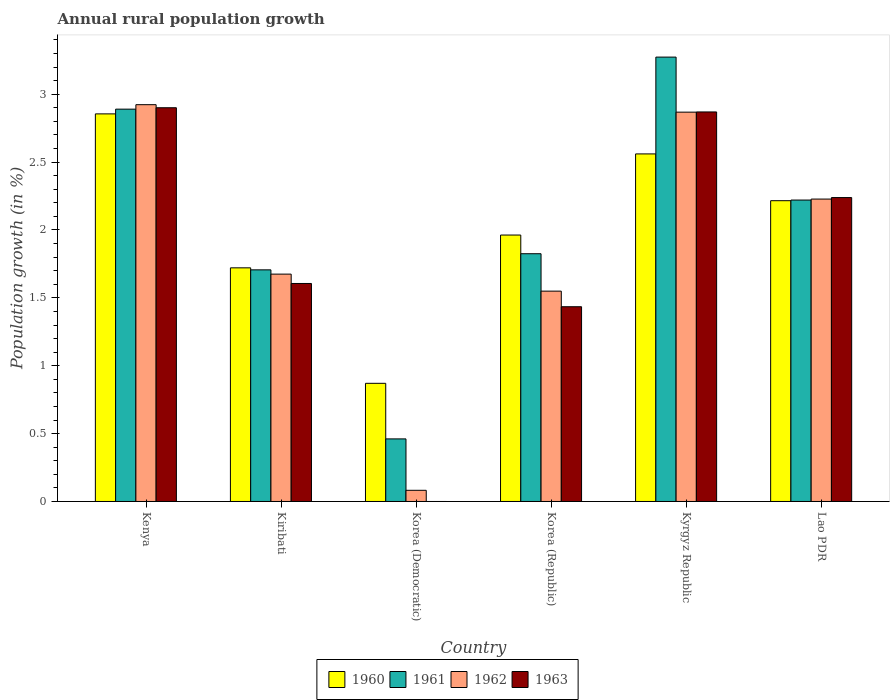Are the number of bars per tick equal to the number of legend labels?
Offer a very short reply. No. Are the number of bars on each tick of the X-axis equal?
Your answer should be very brief. No. How many bars are there on the 2nd tick from the left?
Your answer should be compact. 4. How many bars are there on the 5th tick from the right?
Provide a short and direct response. 4. What is the label of the 3rd group of bars from the left?
Offer a terse response. Korea (Democratic). Across all countries, what is the maximum percentage of rural population growth in 1960?
Give a very brief answer. 2.86. Across all countries, what is the minimum percentage of rural population growth in 1960?
Provide a succinct answer. 0.87. In which country was the percentage of rural population growth in 1962 maximum?
Your answer should be very brief. Kenya. What is the total percentage of rural population growth in 1961 in the graph?
Ensure brevity in your answer.  12.38. What is the difference between the percentage of rural population growth in 1961 in Kyrgyz Republic and that in Lao PDR?
Provide a succinct answer. 1.05. What is the difference between the percentage of rural population growth in 1960 in Kyrgyz Republic and the percentage of rural population growth in 1962 in Lao PDR?
Provide a short and direct response. 0.33. What is the average percentage of rural population growth in 1960 per country?
Provide a short and direct response. 2.03. What is the difference between the percentage of rural population growth of/in 1961 and percentage of rural population growth of/in 1963 in Korea (Republic)?
Give a very brief answer. 0.39. In how many countries, is the percentage of rural population growth in 1960 greater than 3.3 %?
Your response must be concise. 0. What is the ratio of the percentage of rural population growth in 1961 in Kenya to that in Korea (Democratic)?
Provide a succinct answer. 6.27. Is the percentage of rural population growth in 1961 in Korea (Democratic) less than that in Lao PDR?
Make the answer very short. Yes. Is the difference between the percentage of rural population growth in 1961 in Kiribati and Korea (Republic) greater than the difference between the percentage of rural population growth in 1963 in Kiribati and Korea (Republic)?
Your response must be concise. No. What is the difference between the highest and the second highest percentage of rural population growth in 1961?
Make the answer very short. -0.38. What is the difference between the highest and the lowest percentage of rural population growth in 1963?
Offer a very short reply. 2.9. In how many countries, is the percentage of rural population growth in 1963 greater than the average percentage of rural population growth in 1963 taken over all countries?
Give a very brief answer. 3. Is it the case that in every country, the sum of the percentage of rural population growth in 1960 and percentage of rural population growth in 1963 is greater than the percentage of rural population growth in 1962?
Provide a short and direct response. Yes. What is the difference between two consecutive major ticks on the Y-axis?
Provide a succinct answer. 0.5. Are the values on the major ticks of Y-axis written in scientific E-notation?
Give a very brief answer. No. Does the graph contain any zero values?
Your answer should be compact. Yes. Does the graph contain grids?
Make the answer very short. No. How are the legend labels stacked?
Provide a short and direct response. Horizontal. What is the title of the graph?
Your answer should be very brief. Annual rural population growth. Does "1989" appear as one of the legend labels in the graph?
Give a very brief answer. No. What is the label or title of the X-axis?
Make the answer very short. Country. What is the label or title of the Y-axis?
Keep it short and to the point. Population growth (in %). What is the Population growth (in %) of 1960 in Kenya?
Offer a very short reply. 2.86. What is the Population growth (in %) in 1961 in Kenya?
Offer a very short reply. 2.89. What is the Population growth (in %) of 1962 in Kenya?
Provide a short and direct response. 2.92. What is the Population growth (in %) of 1963 in Kenya?
Your response must be concise. 2.9. What is the Population growth (in %) of 1960 in Kiribati?
Ensure brevity in your answer.  1.72. What is the Population growth (in %) of 1961 in Kiribati?
Make the answer very short. 1.71. What is the Population growth (in %) of 1962 in Kiribati?
Ensure brevity in your answer.  1.67. What is the Population growth (in %) of 1963 in Kiribati?
Your answer should be compact. 1.61. What is the Population growth (in %) in 1960 in Korea (Democratic)?
Keep it short and to the point. 0.87. What is the Population growth (in %) in 1961 in Korea (Democratic)?
Provide a succinct answer. 0.46. What is the Population growth (in %) in 1962 in Korea (Democratic)?
Provide a succinct answer. 0.08. What is the Population growth (in %) in 1960 in Korea (Republic)?
Give a very brief answer. 1.96. What is the Population growth (in %) in 1961 in Korea (Republic)?
Your answer should be compact. 1.83. What is the Population growth (in %) in 1962 in Korea (Republic)?
Offer a terse response. 1.55. What is the Population growth (in %) of 1963 in Korea (Republic)?
Ensure brevity in your answer.  1.43. What is the Population growth (in %) of 1960 in Kyrgyz Republic?
Give a very brief answer. 2.56. What is the Population growth (in %) of 1961 in Kyrgyz Republic?
Offer a very short reply. 3.27. What is the Population growth (in %) of 1962 in Kyrgyz Republic?
Give a very brief answer. 2.87. What is the Population growth (in %) of 1963 in Kyrgyz Republic?
Your answer should be very brief. 2.87. What is the Population growth (in %) of 1960 in Lao PDR?
Provide a short and direct response. 2.22. What is the Population growth (in %) in 1961 in Lao PDR?
Ensure brevity in your answer.  2.22. What is the Population growth (in %) of 1962 in Lao PDR?
Keep it short and to the point. 2.23. What is the Population growth (in %) in 1963 in Lao PDR?
Ensure brevity in your answer.  2.24. Across all countries, what is the maximum Population growth (in %) in 1960?
Offer a terse response. 2.86. Across all countries, what is the maximum Population growth (in %) of 1961?
Keep it short and to the point. 3.27. Across all countries, what is the maximum Population growth (in %) in 1962?
Provide a short and direct response. 2.92. Across all countries, what is the maximum Population growth (in %) in 1963?
Ensure brevity in your answer.  2.9. Across all countries, what is the minimum Population growth (in %) of 1960?
Offer a terse response. 0.87. Across all countries, what is the minimum Population growth (in %) in 1961?
Your answer should be very brief. 0.46. Across all countries, what is the minimum Population growth (in %) of 1962?
Make the answer very short. 0.08. What is the total Population growth (in %) in 1960 in the graph?
Your answer should be compact. 12.19. What is the total Population growth (in %) in 1961 in the graph?
Make the answer very short. 12.38. What is the total Population growth (in %) of 1962 in the graph?
Ensure brevity in your answer.  11.33. What is the total Population growth (in %) in 1963 in the graph?
Your response must be concise. 11.05. What is the difference between the Population growth (in %) in 1960 in Kenya and that in Kiribati?
Your response must be concise. 1.13. What is the difference between the Population growth (in %) of 1961 in Kenya and that in Kiribati?
Provide a succinct answer. 1.18. What is the difference between the Population growth (in %) in 1962 in Kenya and that in Kiribati?
Keep it short and to the point. 1.25. What is the difference between the Population growth (in %) of 1963 in Kenya and that in Kiribati?
Give a very brief answer. 1.29. What is the difference between the Population growth (in %) of 1960 in Kenya and that in Korea (Democratic)?
Provide a short and direct response. 1.98. What is the difference between the Population growth (in %) in 1961 in Kenya and that in Korea (Democratic)?
Your response must be concise. 2.43. What is the difference between the Population growth (in %) of 1962 in Kenya and that in Korea (Democratic)?
Provide a succinct answer. 2.84. What is the difference between the Population growth (in %) of 1960 in Kenya and that in Korea (Republic)?
Your answer should be very brief. 0.89. What is the difference between the Population growth (in %) in 1961 in Kenya and that in Korea (Republic)?
Make the answer very short. 1.07. What is the difference between the Population growth (in %) in 1962 in Kenya and that in Korea (Republic)?
Your answer should be very brief. 1.37. What is the difference between the Population growth (in %) of 1963 in Kenya and that in Korea (Republic)?
Your response must be concise. 1.47. What is the difference between the Population growth (in %) of 1960 in Kenya and that in Kyrgyz Republic?
Keep it short and to the point. 0.29. What is the difference between the Population growth (in %) of 1961 in Kenya and that in Kyrgyz Republic?
Make the answer very short. -0.38. What is the difference between the Population growth (in %) of 1962 in Kenya and that in Kyrgyz Republic?
Ensure brevity in your answer.  0.06. What is the difference between the Population growth (in %) in 1963 in Kenya and that in Kyrgyz Republic?
Your answer should be very brief. 0.03. What is the difference between the Population growth (in %) of 1960 in Kenya and that in Lao PDR?
Your answer should be very brief. 0.64. What is the difference between the Population growth (in %) in 1961 in Kenya and that in Lao PDR?
Provide a succinct answer. 0.67. What is the difference between the Population growth (in %) in 1962 in Kenya and that in Lao PDR?
Make the answer very short. 0.7. What is the difference between the Population growth (in %) of 1963 in Kenya and that in Lao PDR?
Your answer should be very brief. 0.66. What is the difference between the Population growth (in %) of 1960 in Kiribati and that in Korea (Democratic)?
Offer a terse response. 0.85. What is the difference between the Population growth (in %) in 1961 in Kiribati and that in Korea (Democratic)?
Keep it short and to the point. 1.25. What is the difference between the Population growth (in %) of 1962 in Kiribati and that in Korea (Democratic)?
Your answer should be compact. 1.59. What is the difference between the Population growth (in %) in 1960 in Kiribati and that in Korea (Republic)?
Give a very brief answer. -0.24. What is the difference between the Population growth (in %) of 1961 in Kiribati and that in Korea (Republic)?
Your response must be concise. -0.12. What is the difference between the Population growth (in %) of 1962 in Kiribati and that in Korea (Republic)?
Ensure brevity in your answer.  0.13. What is the difference between the Population growth (in %) of 1963 in Kiribati and that in Korea (Republic)?
Offer a very short reply. 0.17. What is the difference between the Population growth (in %) of 1960 in Kiribati and that in Kyrgyz Republic?
Your answer should be very brief. -0.84. What is the difference between the Population growth (in %) in 1961 in Kiribati and that in Kyrgyz Republic?
Offer a very short reply. -1.57. What is the difference between the Population growth (in %) of 1962 in Kiribati and that in Kyrgyz Republic?
Offer a very short reply. -1.19. What is the difference between the Population growth (in %) of 1963 in Kiribati and that in Kyrgyz Republic?
Make the answer very short. -1.26. What is the difference between the Population growth (in %) in 1960 in Kiribati and that in Lao PDR?
Give a very brief answer. -0.49. What is the difference between the Population growth (in %) of 1961 in Kiribati and that in Lao PDR?
Give a very brief answer. -0.51. What is the difference between the Population growth (in %) in 1962 in Kiribati and that in Lao PDR?
Offer a terse response. -0.55. What is the difference between the Population growth (in %) in 1963 in Kiribati and that in Lao PDR?
Offer a very short reply. -0.63. What is the difference between the Population growth (in %) of 1960 in Korea (Democratic) and that in Korea (Republic)?
Keep it short and to the point. -1.09. What is the difference between the Population growth (in %) in 1961 in Korea (Democratic) and that in Korea (Republic)?
Provide a succinct answer. -1.36. What is the difference between the Population growth (in %) of 1962 in Korea (Democratic) and that in Korea (Republic)?
Your response must be concise. -1.47. What is the difference between the Population growth (in %) of 1960 in Korea (Democratic) and that in Kyrgyz Republic?
Make the answer very short. -1.69. What is the difference between the Population growth (in %) of 1961 in Korea (Democratic) and that in Kyrgyz Republic?
Keep it short and to the point. -2.81. What is the difference between the Population growth (in %) in 1962 in Korea (Democratic) and that in Kyrgyz Republic?
Offer a terse response. -2.79. What is the difference between the Population growth (in %) of 1960 in Korea (Democratic) and that in Lao PDR?
Keep it short and to the point. -1.35. What is the difference between the Population growth (in %) of 1961 in Korea (Democratic) and that in Lao PDR?
Your response must be concise. -1.76. What is the difference between the Population growth (in %) in 1962 in Korea (Democratic) and that in Lao PDR?
Keep it short and to the point. -2.15. What is the difference between the Population growth (in %) in 1960 in Korea (Republic) and that in Kyrgyz Republic?
Provide a succinct answer. -0.6. What is the difference between the Population growth (in %) of 1961 in Korea (Republic) and that in Kyrgyz Republic?
Provide a succinct answer. -1.45. What is the difference between the Population growth (in %) of 1962 in Korea (Republic) and that in Kyrgyz Republic?
Offer a very short reply. -1.32. What is the difference between the Population growth (in %) in 1963 in Korea (Republic) and that in Kyrgyz Republic?
Ensure brevity in your answer.  -1.43. What is the difference between the Population growth (in %) in 1960 in Korea (Republic) and that in Lao PDR?
Give a very brief answer. -0.25. What is the difference between the Population growth (in %) in 1961 in Korea (Republic) and that in Lao PDR?
Your response must be concise. -0.4. What is the difference between the Population growth (in %) in 1962 in Korea (Republic) and that in Lao PDR?
Your answer should be very brief. -0.68. What is the difference between the Population growth (in %) in 1963 in Korea (Republic) and that in Lao PDR?
Offer a terse response. -0.8. What is the difference between the Population growth (in %) in 1960 in Kyrgyz Republic and that in Lao PDR?
Provide a succinct answer. 0.34. What is the difference between the Population growth (in %) in 1961 in Kyrgyz Republic and that in Lao PDR?
Offer a very short reply. 1.05. What is the difference between the Population growth (in %) of 1962 in Kyrgyz Republic and that in Lao PDR?
Provide a succinct answer. 0.64. What is the difference between the Population growth (in %) of 1963 in Kyrgyz Republic and that in Lao PDR?
Ensure brevity in your answer.  0.63. What is the difference between the Population growth (in %) of 1960 in Kenya and the Population growth (in %) of 1961 in Kiribati?
Your response must be concise. 1.15. What is the difference between the Population growth (in %) of 1960 in Kenya and the Population growth (in %) of 1962 in Kiribati?
Offer a terse response. 1.18. What is the difference between the Population growth (in %) in 1960 in Kenya and the Population growth (in %) in 1963 in Kiribati?
Your response must be concise. 1.25. What is the difference between the Population growth (in %) in 1961 in Kenya and the Population growth (in %) in 1962 in Kiribati?
Keep it short and to the point. 1.22. What is the difference between the Population growth (in %) in 1961 in Kenya and the Population growth (in %) in 1963 in Kiribati?
Offer a very short reply. 1.28. What is the difference between the Population growth (in %) of 1962 in Kenya and the Population growth (in %) of 1963 in Kiribati?
Provide a succinct answer. 1.32. What is the difference between the Population growth (in %) of 1960 in Kenya and the Population growth (in %) of 1961 in Korea (Democratic)?
Offer a terse response. 2.39. What is the difference between the Population growth (in %) of 1960 in Kenya and the Population growth (in %) of 1962 in Korea (Democratic)?
Offer a very short reply. 2.77. What is the difference between the Population growth (in %) of 1961 in Kenya and the Population growth (in %) of 1962 in Korea (Democratic)?
Offer a very short reply. 2.81. What is the difference between the Population growth (in %) of 1960 in Kenya and the Population growth (in %) of 1961 in Korea (Republic)?
Your answer should be compact. 1.03. What is the difference between the Population growth (in %) in 1960 in Kenya and the Population growth (in %) in 1962 in Korea (Republic)?
Your answer should be compact. 1.31. What is the difference between the Population growth (in %) of 1960 in Kenya and the Population growth (in %) of 1963 in Korea (Republic)?
Provide a succinct answer. 1.42. What is the difference between the Population growth (in %) of 1961 in Kenya and the Population growth (in %) of 1962 in Korea (Republic)?
Your answer should be very brief. 1.34. What is the difference between the Population growth (in %) in 1961 in Kenya and the Population growth (in %) in 1963 in Korea (Republic)?
Ensure brevity in your answer.  1.46. What is the difference between the Population growth (in %) of 1962 in Kenya and the Population growth (in %) of 1963 in Korea (Republic)?
Offer a terse response. 1.49. What is the difference between the Population growth (in %) of 1960 in Kenya and the Population growth (in %) of 1961 in Kyrgyz Republic?
Provide a short and direct response. -0.42. What is the difference between the Population growth (in %) of 1960 in Kenya and the Population growth (in %) of 1962 in Kyrgyz Republic?
Give a very brief answer. -0.01. What is the difference between the Population growth (in %) of 1960 in Kenya and the Population growth (in %) of 1963 in Kyrgyz Republic?
Keep it short and to the point. -0.01. What is the difference between the Population growth (in %) of 1961 in Kenya and the Population growth (in %) of 1962 in Kyrgyz Republic?
Offer a very short reply. 0.02. What is the difference between the Population growth (in %) of 1961 in Kenya and the Population growth (in %) of 1963 in Kyrgyz Republic?
Your answer should be compact. 0.02. What is the difference between the Population growth (in %) of 1962 in Kenya and the Population growth (in %) of 1963 in Kyrgyz Republic?
Provide a succinct answer. 0.05. What is the difference between the Population growth (in %) in 1960 in Kenya and the Population growth (in %) in 1961 in Lao PDR?
Give a very brief answer. 0.63. What is the difference between the Population growth (in %) of 1960 in Kenya and the Population growth (in %) of 1962 in Lao PDR?
Offer a terse response. 0.63. What is the difference between the Population growth (in %) in 1960 in Kenya and the Population growth (in %) in 1963 in Lao PDR?
Offer a terse response. 0.62. What is the difference between the Population growth (in %) in 1961 in Kenya and the Population growth (in %) in 1962 in Lao PDR?
Offer a very short reply. 0.66. What is the difference between the Population growth (in %) of 1961 in Kenya and the Population growth (in %) of 1963 in Lao PDR?
Make the answer very short. 0.65. What is the difference between the Population growth (in %) in 1962 in Kenya and the Population growth (in %) in 1963 in Lao PDR?
Make the answer very short. 0.68. What is the difference between the Population growth (in %) of 1960 in Kiribati and the Population growth (in %) of 1961 in Korea (Democratic)?
Offer a very short reply. 1.26. What is the difference between the Population growth (in %) of 1960 in Kiribati and the Population growth (in %) of 1962 in Korea (Democratic)?
Your answer should be very brief. 1.64. What is the difference between the Population growth (in %) in 1961 in Kiribati and the Population growth (in %) in 1962 in Korea (Democratic)?
Provide a succinct answer. 1.62. What is the difference between the Population growth (in %) in 1960 in Kiribati and the Population growth (in %) in 1961 in Korea (Republic)?
Your answer should be very brief. -0.1. What is the difference between the Population growth (in %) of 1960 in Kiribati and the Population growth (in %) of 1962 in Korea (Republic)?
Offer a terse response. 0.17. What is the difference between the Population growth (in %) of 1960 in Kiribati and the Population growth (in %) of 1963 in Korea (Republic)?
Give a very brief answer. 0.29. What is the difference between the Population growth (in %) in 1961 in Kiribati and the Population growth (in %) in 1962 in Korea (Republic)?
Provide a succinct answer. 0.16. What is the difference between the Population growth (in %) in 1961 in Kiribati and the Population growth (in %) in 1963 in Korea (Republic)?
Offer a terse response. 0.27. What is the difference between the Population growth (in %) of 1962 in Kiribati and the Population growth (in %) of 1963 in Korea (Republic)?
Ensure brevity in your answer.  0.24. What is the difference between the Population growth (in %) in 1960 in Kiribati and the Population growth (in %) in 1961 in Kyrgyz Republic?
Your response must be concise. -1.55. What is the difference between the Population growth (in %) in 1960 in Kiribati and the Population growth (in %) in 1962 in Kyrgyz Republic?
Provide a succinct answer. -1.15. What is the difference between the Population growth (in %) in 1960 in Kiribati and the Population growth (in %) in 1963 in Kyrgyz Republic?
Give a very brief answer. -1.15. What is the difference between the Population growth (in %) of 1961 in Kiribati and the Population growth (in %) of 1962 in Kyrgyz Republic?
Your answer should be compact. -1.16. What is the difference between the Population growth (in %) of 1961 in Kiribati and the Population growth (in %) of 1963 in Kyrgyz Republic?
Offer a very short reply. -1.16. What is the difference between the Population growth (in %) in 1962 in Kiribati and the Population growth (in %) in 1963 in Kyrgyz Republic?
Keep it short and to the point. -1.19. What is the difference between the Population growth (in %) of 1960 in Kiribati and the Population growth (in %) of 1961 in Lao PDR?
Provide a succinct answer. -0.5. What is the difference between the Population growth (in %) in 1960 in Kiribati and the Population growth (in %) in 1962 in Lao PDR?
Keep it short and to the point. -0.51. What is the difference between the Population growth (in %) in 1960 in Kiribati and the Population growth (in %) in 1963 in Lao PDR?
Offer a very short reply. -0.52. What is the difference between the Population growth (in %) of 1961 in Kiribati and the Population growth (in %) of 1962 in Lao PDR?
Ensure brevity in your answer.  -0.52. What is the difference between the Population growth (in %) in 1961 in Kiribati and the Population growth (in %) in 1963 in Lao PDR?
Make the answer very short. -0.53. What is the difference between the Population growth (in %) of 1962 in Kiribati and the Population growth (in %) of 1963 in Lao PDR?
Offer a terse response. -0.56. What is the difference between the Population growth (in %) in 1960 in Korea (Democratic) and the Population growth (in %) in 1961 in Korea (Republic)?
Make the answer very short. -0.95. What is the difference between the Population growth (in %) in 1960 in Korea (Democratic) and the Population growth (in %) in 1962 in Korea (Republic)?
Make the answer very short. -0.68. What is the difference between the Population growth (in %) of 1960 in Korea (Democratic) and the Population growth (in %) of 1963 in Korea (Republic)?
Make the answer very short. -0.56. What is the difference between the Population growth (in %) in 1961 in Korea (Democratic) and the Population growth (in %) in 1962 in Korea (Republic)?
Your answer should be compact. -1.09. What is the difference between the Population growth (in %) of 1961 in Korea (Democratic) and the Population growth (in %) of 1963 in Korea (Republic)?
Offer a very short reply. -0.97. What is the difference between the Population growth (in %) of 1962 in Korea (Democratic) and the Population growth (in %) of 1963 in Korea (Republic)?
Give a very brief answer. -1.35. What is the difference between the Population growth (in %) in 1960 in Korea (Democratic) and the Population growth (in %) in 1961 in Kyrgyz Republic?
Make the answer very short. -2.4. What is the difference between the Population growth (in %) of 1960 in Korea (Democratic) and the Population growth (in %) of 1962 in Kyrgyz Republic?
Provide a succinct answer. -2. What is the difference between the Population growth (in %) of 1960 in Korea (Democratic) and the Population growth (in %) of 1963 in Kyrgyz Republic?
Ensure brevity in your answer.  -2. What is the difference between the Population growth (in %) of 1961 in Korea (Democratic) and the Population growth (in %) of 1962 in Kyrgyz Republic?
Your answer should be very brief. -2.41. What is the difference between the Population growth (in %) of 1961 in Korea (Democratic) and the Population growth (in %) of 1963 in Kyrgyz Republic?
Keep it short and to the point. -2.41. What is the difference between the Population growth (in %) in 1962 in Korea (Democratic) and the Population growth (in %) in 1963 in Kyrgyz Republic?
Your answer should be compact. -2.79. What is the difference between the Population growth (in %) in 1960 in Korea (Democratic) and the Population growth (in %) in 1961 in Lao PDR?
Provide a short and direct response. -1.35. What is the difference between the Population growth (in %) in 1960 in Korea (Democratic) and the Population growth (in %) in 1962 in Lao PDR?
Your response must be concise. -1.36. What is the difference between the Population growth (in %) of 1960 in Korea (Democratic) and the Population growth (in %) of 1963 in Lao PDR?
Your answer should be very brief. -1.37. What is the difference between the Population growth (in %) of 1961 in Korea (Democratic) and the Population growth (in %) of 1962 in Lao PDR?
Offer a very short reply. -1.77. What is the difference between the Population growth (in %) of 1961 in Korea (Democratic) and the Population growth (in %) of 1963 in Lao PDR?
Your response must be concise. -1.78. What is the difference between the Population growth (in %) of 1962 in Korea (Democratic) and the Population growth (in %) of 1963 in Lao PDR?
Keep it short and to the point. -2.16. What is the difference between the Population growth (in %) of 1960 in Korea (Republic) and the Population growth (in %) of 1961 in Kyrgyz Republic?
Provide a short and direct response. -1.31. What is the difference between the Population growth (in %) of 1960 in Korea (Republic) and the Population growth (in %) of 1962 in Kyrgyz Republic?
Your answer should be compact. -0.91. What is the difference between the Population growth (in %) of 1960 in Korea (Republic) and the Population growth (in %) of 1963 in Kyrgyz Republic?
Keep it short and to the point. -0.91. What is the difference between the Population growth (in %) in 1961 in Korea (Republic) and the Population growth (in %) in 1962 in Kyrgyz Republic?
Your answer should be compact. -1.04. What is the difference between the Population growth (in %) of 1961 in Korea (Republic) and the Population growth (in %) of 1963 in Kyrgyz Republic?
Offer a terse response. -1.04. What is the difference between the Population growth (in %) of 1962 in Korea (Republic) and the Population growth (in %) of 1963 in Kyrgyz Republic?
Provide a succinct answer. -1.32. What is the difference between the Population growth (in %) in 1960 in Korea (Republic) and the Population growth (in %) in 1961 in Lao PDR?
Your answer should be very brief. -0.26. What is the difference between the Population growth (in %) in 1960 in Korea (Republic) and the Population growth (in %) in 1962 in Lao PDR?
Offer a very short reply. -0.26. What is the difference between the Population growth (in %) of 1960 in Korea (Republic) and the Population growth (in %) of 1963 in Lao PDR?
Offer a very short reply. -0.28. What is the difference between the Population growth (in %) in 1961 in Korea (Republic) and the Population growth (in %) in 1962 in Lao PDR?
Ensure brevity in your answer.  -0.4. What is the difference between the Population growth (in %) of 1961 in Korea (Republic) and the Population growth (in %) of 1963 in Lao PDR?
Keep it short and to the point. -0.41. What is the difference between the Population growth (in %) of 1962 in Korea (Republic) and the Population growth (in %) of 1963 in Lao PDR?
Provide a succinct answer. -0.69. What is the difference between the Population growth (in %) in 1960 in Kyrgyz Republic and the Population growth (in %) in 1961 in Lao PDR?
Your answer should be compact. 0.34. What is the difference between the Population growth (in %) in 1960 in Kyrgyz Republic and the Population growth (in %) in 1962 in Lao PDR?
Your answer should be compact. 0.33. What is the difference between the Population growth (in %) in 1960 in Kyrgyz Republic and the Population growth (in %) in 1963 in Lao PDR?
Keep it short and to the point. 0.32. What is the difference between the Population growth (in %) of 1961 in Kyrgyz Republic and the Population growth (in %) of 1962 in Lao PDR?
Make the answer very short. 1.05. What is the difference between the Population growth (in %) in 1961 in Kyrgyz Republic and the Population growth (in %) in 1963 in Lao PDR?
Provide a short and direct response. 1.03. What is the difference between the Population growth (in %) in 1962 in Kyrgyz Republic and the Population growth (in %) in 1963 in Lao PDR?
Give a very brief answer. 0.63. What is the average Population growth (in %) of 1960 per country?
Ensure brevity in your answer.  2.03. What is the average Population growth (in %) in 1961 per country?
Your response must be concise. 2.06. What is the average Population growth (in %) of 1962 per country?
Provide a succinct answer. 1.89. What is the average Population growth (in %) in 1963 per country?
Offer a terse response. 1.84. What is the difference between the Population growth (in %) of 1960 and Population growth (in %) of 1961 in Kenya?
Provide a short and direct response. -0.03. What is the difference between the Population growth (in %) of 1960 and Population growth (in %) of 1962 in Kenya?
Provide a short and direct response. -0.07. What is the difference between the Population growth (in %) in 1960 and Population growth (in %) in 1963 in Kenya?
Provide a succinct answer. -0.05. What is the difference between the Population growth (in %) in 1961 and Population growth (in %) in 1962 in Kenya?
Offer a very short reply. -0.03. What is the difference between the Population growth (in %) of 1961 and Population growth (in %) of 1963 in Kenya?
Provide a succinct answer. -0.01. What is the difference between the Population growth (in %) in 1962 and Population growth (in %) in 1963 in Kenya?
Provide a short and direct response. 0.02. What is the difference between the Population growth (in %) of 1960 and Population growth (in %) of 1961 in Kiribati?
Keep it short and to the point. 0.01. What is the difference between the Population growth (in %) in 1960 and Population growth (in %) in 1962 in Kiribati?
Your answer should be very brief. 0.05. What is the difference between the Population growth (in %) of 1960 and Population growth (in %) of 1963 in Kiribati?
Provide a short and direct response. 0.12. What is the difference between the Population growth (in %) of 1961 and Population growth (in %) of 1962 in Kiribati?
Give a very brief answer. 0.03. What is the difference between the Population growth (in %) in 1961 and Population growth (in %) in 1963 in Kiribati?
Your response must be concise. 0.1. What is the difference between the Population growth (in %) of 1962 and Population growth (in %) of 1963 in Kiribati?
Ensure brevity in your answer.  0.07. What is the difference between the Population growth (in %) in 1960 and Population growth (in %) in 1961 in Korea (Democratic)?
Provide a short and direct response. 0.41. What is the difference between the Population growth (in %) of 1960 and Population growth (in %) of 1962 in Korea (Democratic)?
Offer a very short reply. 0.79. What is the difference between the Population growth (in %) in 1961 and Population growth (in %) in 1962 in Korea (Democratic)?
Your answer should be very brief. 0.38. What is the difference between the Population growth (in %) in 1960 and Population growth (in %) in 1961 in Korea (Republic)?
Make the answer very short. 0.14. What is the difference between the Population growth (in %) in 1960 and Population growth (in %) in 1962 in Korea (Republic)?
Your answer should be very brief. 0.41. What is the difference between the Population growth (in %) in 1960 and Population growth (in %) in 1963 in Korea (Republic)?
Provide a succinct answer. 0.53. What is the difference between the Population growth (in %) in 1961 and Population growth (in %) in 1962 in Korea (Republic)?
Your answer should be very brief. 0.28. What is the difference between the Population growth (in %) in 1961 and Population growth (in %) in 1963 in Korea (Republic)?
Your response must be concise. 0.39. What is the difference between the Population growth (in %) in 1962 and Population growth (in %) in 1963 in Korea (Republic)?
Give a very brief answer. 0.11. What is the difference between the Population growth (in %) of 1960 and Population growth (in %) of 1961 in Kyrgyz Republic?
Your answer should be very brief. -0.71. What is the difference between the Population growth (in %) of 1960 and Population growth (in %) of 1962 in Kyrgyz Republic?
Your response must be concise. -0.31. What is the difference between the Population growth (in %) of 1960 and Population growth (in %) of 1963 in Kyrgyz Republic?
Your response must be concise. -0.31. What is the difference between the Population growth (in %) in 1961 and Population growth (in %) in 1962 in Kyrgyz Republic?
Make the answer very short. 0.41. What is the difference between the Population growth (in %) of 1961 and Population growth (in %) of 1963 in Kyrgyz Republic?
Make the answer very short. 0.4. What is the difference between the Population growth (in %) of 1962 and Population growth (in %) of 1963 in Kyrgyz Republic?
Give a very brief answer. -0. What is the difference between the Population growth (in %) in 1960 and Population growth (in %) in 1961 in Lao PDR?
Your answer should be compact. -0. What is the difference between the Population growth (in %) of 1960 and Population growth (in %) of 1962 in Lao PDR?
Keep it short and to the point. -0.01. What is the difference between the Population growth (in %) of 1960 and Population growth (in %) of 1963 in Lao PDR?
Give a very brief answer. -0.02. What is the difference between the Population growth (in %) in 1961 and Population growth (in %) in 1962 in Lao PDR?
Your answer should be very brief. -0.01. What is the difference between the Population growth (in %) of 1961 and Population growth (in %) of 1963 in Lao PDR?
Provide a succinct answer. -0.02. What is the difference between the Population growth (in %) in 1962 and Population growth (in %) in 1963 in Lao PDR?
Keep it short and to the point. -0.01. What is the ratio of the Population growth (in %) of 1960 in Kenya to that in Kiribati?
Your answer should be very brief. 1.66. What is the ratio of the Population growth (in %) in 1961 in Kenya to that in Kiribati?
Ensure brevity in your answer.  1.69. What is the ratio of the Population growth (in %) in 1962 in Kenya to that in Kiribati?
Your answer should be compact. 1.75. What is the ratio of the Population growth (in %) of 1963 in Kenya to that in Kiribati?
Your answer should be very brief. 1.81. What is the ratio of the Population growth (in %) of 1960 in Kenya to that in Korea (Democratic)?
Your response must be concise. 3.28. What is the ratio of the Population growth (in %) of 1961 in Kenya to that in Korea (Democratic)?
Your response must be concise. 6.27. What is the ratio of the Population growth (in %) of 1962 in Kenya to that in Korea (Democratic)?
Give a very brief answer. 35.53. What is the ratio of the Population growth (in %) in 1960 in Kenya to that in Korea (Republic)?
Provide a short and direct response. 1.45. What is the ratio of the Population growth (in %) of 1961 in Kenya to that in Korea (Republic)?
Provide a succinct answer. 1.58. What is the ratio of the Population growth (in %) of 1962 in Kenya to that in Korea (Republic)?
Offer a very short reply. 1.89. What is the ratio of the Population growth (in %) in 1963 in Kenya to that in Korea (Republic)?
Your answer should be compact. 2.02. What is the ratio of the Population growth (in %) of 1960 in Kenya to that in Kyrgyz Republic?
Your answer should be compact. 1.12. What is the ratio of the Population growth (in %) of 1961 in Kenya to that in Kyrgyz Republic?
Offer a terse response. 0.88. What is the ratio of the Population growth (in %) of 1962 in Kenya to that in Kyrgyz Republic?
Your response must be concise. 1.02. What is the ratio of the Population growth (in %) in 1963 in Kenya to that in Kyrgyz Republic?
Make the answer very short. 1.01. What is the ratio of the Population growth (in %) of 1960 in Kenya to that in Lao PDR?
Make the answer very short. 1.29. What is the ratio of the Population growth (in %) in 1961 in Kenya to that in Lao PDR?
Your response must be concise. 1.3. What is the ratio of the Population growth (in %) in 1962 in Kenya to that in Lao PDR?
Give a very brief answer. 1.31. What is the ratio of the Population growth (in %) of 1963 in Kenya to that in Lao PDR?
Give a very brief answer. 1.3. What is the ratio of the Population growth (in %) in 1960 in Kiribati to that in Korea (Democratic)?
Your answer should be very brief. 1.98. What is the ratio of the Population growth (in %) of 1961 in Kiribati to that in Korea (Democratic)?
Make the answer very short. 3.7. What is the ratio of the Population growth (in %) of 1962 in Kiribati to that in Korea (Democratic)?
Provide a succinct answer. 20.35. What is the ratio of the Population growth (in %) in 1960 in Kiribati to that in Korea (Republic)?
Provide a succinct answer. 0.88. What is the ratio of the Population growth (in %) in 1961 in Kiribati to that in Korea (Republic)?
Your answer should be very brief. 0.93. What is the ratio of the Population growth (in %) in 1962 in Kiribati to that in Korea (Republic)?
Your answer should be very brief. 1.08. What is the ratio of the Population growth (in %) in 1963 in Kiribati to that in Korea (Republic)?
Provide a succinct answer. 1.12. What is the ratio of the Population growth (in %) in 1960 in Kiribati to that in Kyrgyz Republic?
Keep it short and to the point. 0.67. What is the ratio of the Population growth (in %) of 1961 in Kiribati to that in Kyrgyz Republic?
Provide a succinct answer. 0.52. What is the ratio of the Population growth (in %) in 1962 in Kiribati to that in Kyrgyz Republic?
Your response must be concise. 0.58. What is the ratio of the Population growth (in %) of 1963 in Kiribati to that in Kyrgyz Republic?
Your response must be concise. 0.56. What is the ratio of the Population growth (in %) in 1960 in Kiribati to that in Lao PDR?
Your response must be concise. 0.78. What is the ratio of the Population growth (in %) in 1961 in Kiribati to that in Lao PDR?
Make the answer very short. 0.77. What is the ratio of the Population growth (in %) of 1962 in Kiribati to that in Lao PDR?
Your response must be concise. 0.75. What is the ratio of the Population growth (in %) of 1963 in Kiribati to that in Lao PDR?
Provide a succinct answer. 0.72. What is the ratio of the Population growth (in %) in 1960 in Korea (Democratic) to that in Korea (Republic)?
Give a very brief answer. 0.44. What is the ratio of the Population growth (in %) of 1961 in Korea (Democratic) to that in Korea (Republic)?
Keep it short and to the point. 0.25. What is the ratio of the Population growth (in %) of 1962 in Korea (Democratic) to that in Korea (Republic)?
Your response must be concise. 0.05. What is the ratio of the Population growth (in %) of 1960 in Korea (Democratic) to that in Kyrgyz Republic?
Your answer should be very brief. 0.34. What is the ratio of the Population growth (in %) of 1961 in Korea (Democratic) to that in Kyrgyz Republic?
Make the answer very short. 0.14. What is the ratio of the Population growth (in %) in 1962 in Korea (Democratic) to that in Kyrgyz Republic?
Your response must be concise. 0.03. What is the ratio of the Population growth (in %) in 1960 in Korea (Democratic) to that in Lao PDR?
Ensure brevity in your answer.  0.39. What is the ratio of the Population growth (in %) in 1961 in Korea (Democratic) to that in Lao PDR?
Give a very brief answer. 0.21. What is the ratio of the Population growth (in %) in 1962 in Korea (Democratic) to that in Lao PDR?
Make the answer very short. 0.04. What is the ratio of the Population growth (in %) in 1960 in Korea (Republic) to that in Kyrgyz Republic?
Your answer should be very brief. 0.77. What is the ratio of the Population growth (in %) of 1961 in Korea (Republic) to that in Kyrgyz Republic?
Your answer should be very brief. 0.56. What is the ratio of the Population growth (in %) in 1962 in Korea (Republic) to that in Kyrgyz Republic?
Keep it short and to the point. 0.54. What is the ratio of the Population growth (in %) of 1963 in Korea (Republic) to that in Kyrgyz Republic?
Keep it short and to the point. 0.5. What is the ratio of the Population growth (in %) in 1960 in Korea (Republic) to that in Lao PDR?
Offer a very short reply. 0.89. What is the ratio of the Population growth (in %) of 1961 in Korea (Republic) to that in Lao PDR?
Provide a succinct answer. 0.82. What is the ratio of the Population growth (in %) of 1962 in Korea (Republic) to that in Lao PDR?
Ensure brevity in your answer.  0.7. What is the ratio of the Population growth (in %) of 1963 in Korea (Republic) to that in Lao PDR?
Provide a succinct answer. 0.64. What is the ratio of the Population growth (in %) of 1960 in Kyrgyz Republic to that in Lao PDR?
Your answer should be very brief. 1.16. What is the ratio of the Population growth (in %) of 1961 in Kyrgyz Republic to that in Lao PDR?
Provide a short and direct response. 1.47. What is the ratio of the Population growth (in %) in 1962 in Kyrgyz Republic to that in Lao PDR?
Your answer should be very brief. 1.29. What is the ratio of the Population growth (in %) in 1963 in Kyrgyz Republic to that in Lao PDR?
Give a very brief answer. 1.28. What is the difference between the highest and the second highest Population growth (in %) in 1960?
Keep it short and to the point. 0.29. What is the difference between the highest and the second highest Population growth (in %) in 1961?
Provide a succinct answer. 0.38. What is the difference between the highest and the second highest Population growth (in %) in 1962?
Provide a succinct answer. 0.06. What is the difference between the highest and the second highest Population growth (in %) of 1963?
Ensure brevity in your answer.  0.03. What is the difference between the highest and the lowest Population growth (in %) in 1960?
Keep it short and to the point. 1.98. What is the difference between the highest and the lowest Population growth (in %) in 1961?
Offer a very short reply. 2.81. What is the difference between the highest and the lowest Population growth (in %) in 1962?
Make the answer very short. 2.84. What is the difference between the highest and the lowest Population growth (in %) in 1963?
Offer a terse response. 2.9. 